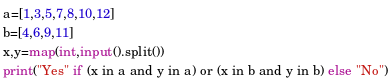<code> <loc_0><loc_0><loc_500><loc_500><_Python_>a=[1,3,5,7,8,10,12]
b=[4,6,9,11]
x,y=map(int,input().split())
print("Yes" if (x in a and y in a) or (x in b and y in b) else "No")</code> 